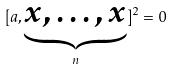<formula> <loc_0><loc_0><loc_500><loc_500>[ a , \underbrace { x , \dots , x } _ { n } ] ^ { 2 } = 0</formula> 